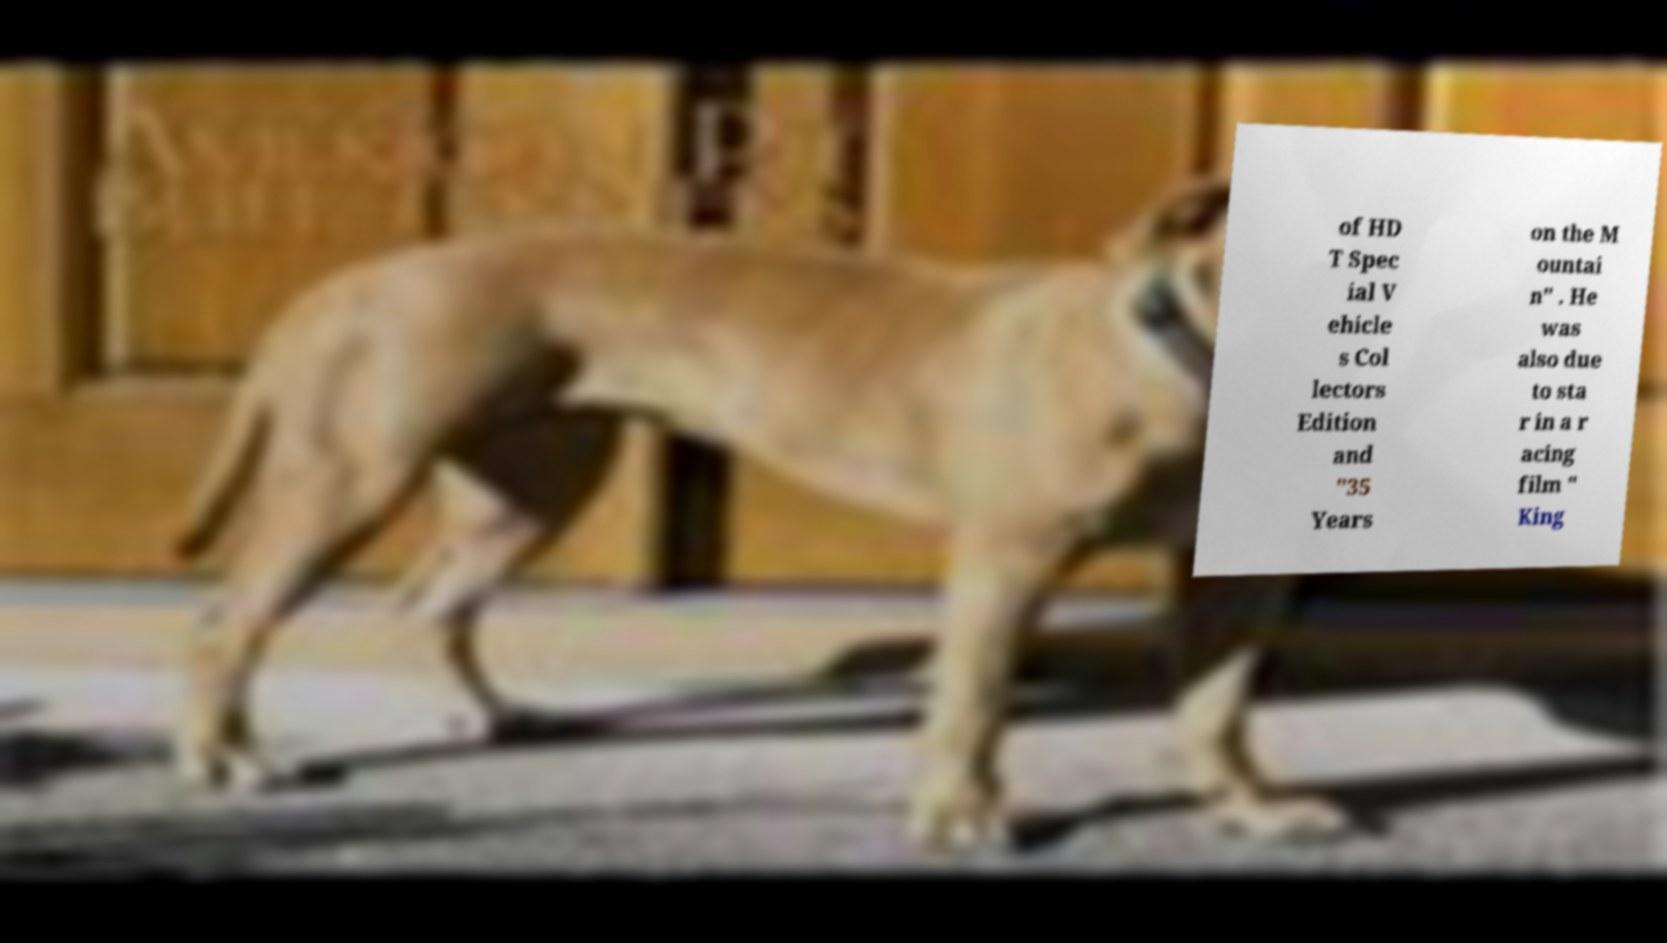There's text embedded in this image that I need extracted. Can you transcribe it verbatim? of HD T Spec ial V ehicle s Col lectors Edition and "35 Years on the M ountai n" . He was also due to sta r in a r acing film " King 